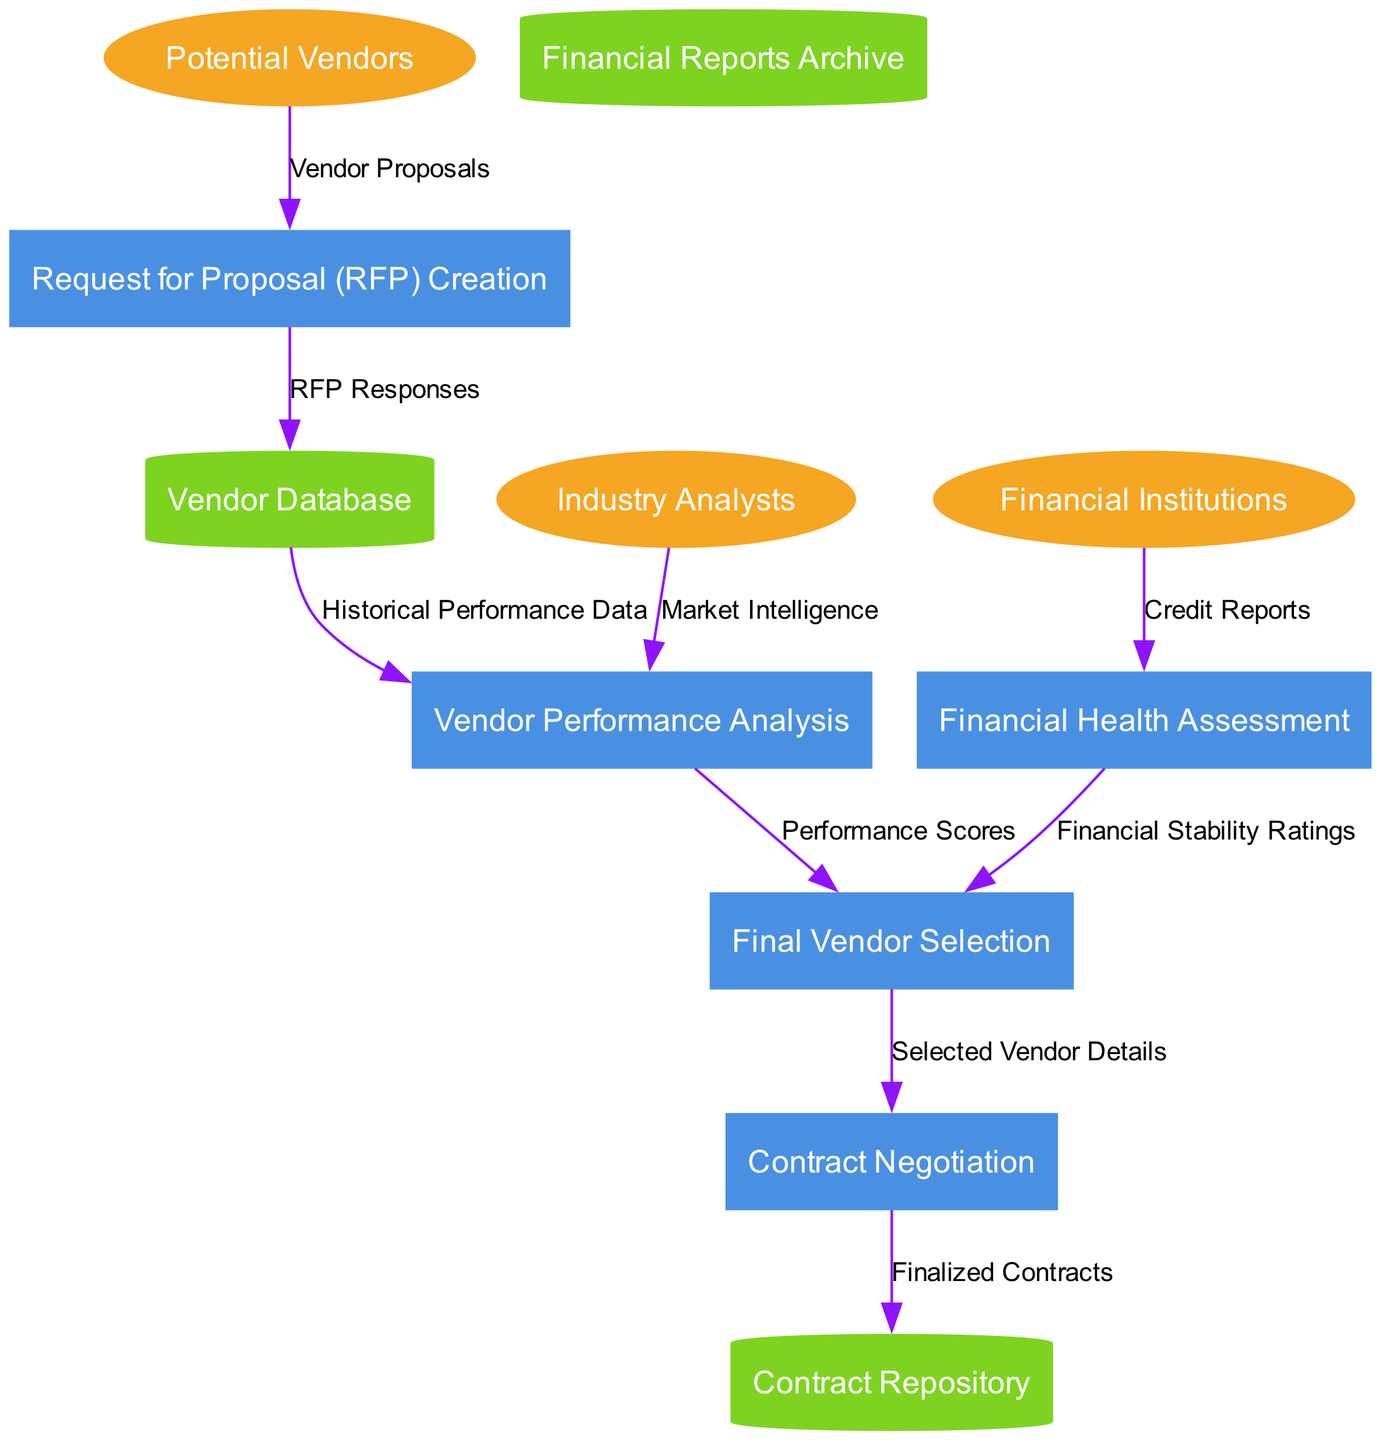What are the external entities in this diagram? The external entities are labeled as ellipses in the diagram. By examining those labels, I identified three entities: "Potential Vendors", "Financial Institutions", and "Industry Analysts".
Answer: Potential Vendors, Financial Institutions, Industry Analysts How many processes are depicted in the diagram? The processes are represented as rectangles. Counting the number of distinct rectangles identified gives a total of five processes present in the diagram.
Answer: 5 Which process receives "Vendor Proposals"? The data flow labeled "Vendor Proposals" originates from "Potential Vendors" and flows into the "Request for Proposal (RFP) Creation" process.
Answer: Request for Proposal (RFP) Creation What data flows into "Vendor Performance Analysis"? The data flows into the "Vendor Performance Analysis" process include "Historical Performance Data" from "Vendor Database" and "Market Intelligence" from "Industry Analysts". Both data flows are essential for the analysis.
Answer: Historical Performance Data, Market Intelligence What is the final output of the vendor selection process? The final output from the "Final Vendor Selection" process is directed towards the "Contract Negotiation" process, represented by the label "Selected Vendor Details".
Answer: Selected Vendor Details Which data store contains "Finalized Contracts"? The "Contract Repository" is the data store that receives data from the "Contract Negotiation" process, as indicated by the data flow labeled "Finalized Contracts".
Answer: Contract Repository What type of reports flow into the "Financial Health Assessment"? The data flowing into the "Financial Health Assessment" process comes specifically in the form of "Credit Reports" from "Financial Institutions".
Answer: Credit Reports Which process leads to the final decision-making process for vendor selection? The "Final Vendor Selection" process follows both the "Vendor Performance Analysis" and "Financial Health Assessment" processes, as both contribute necessary evaluations for the decision-making.
Answer: Final Vendor Selection How many data stores are present in the diagram? The data stores are depicted as cylinders in the diagram. Counting these recognizable shapes gives a total of three data stores.
Answer: 3 